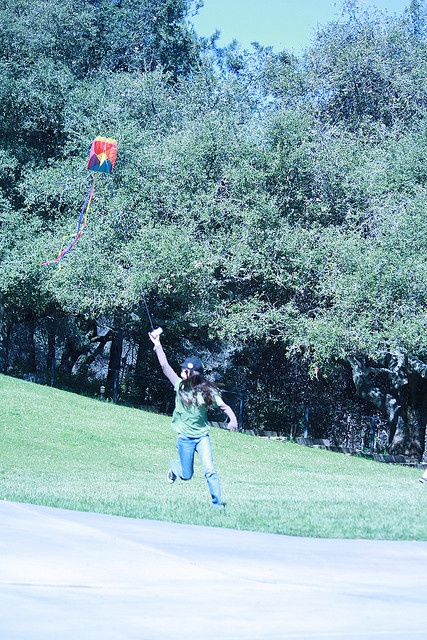Describe the objects in this image and their specific colors. I can see people in gray, lightblue, and teal tones and kite in gray, ivory, blue, salmon, and lightpink tones in this image. 